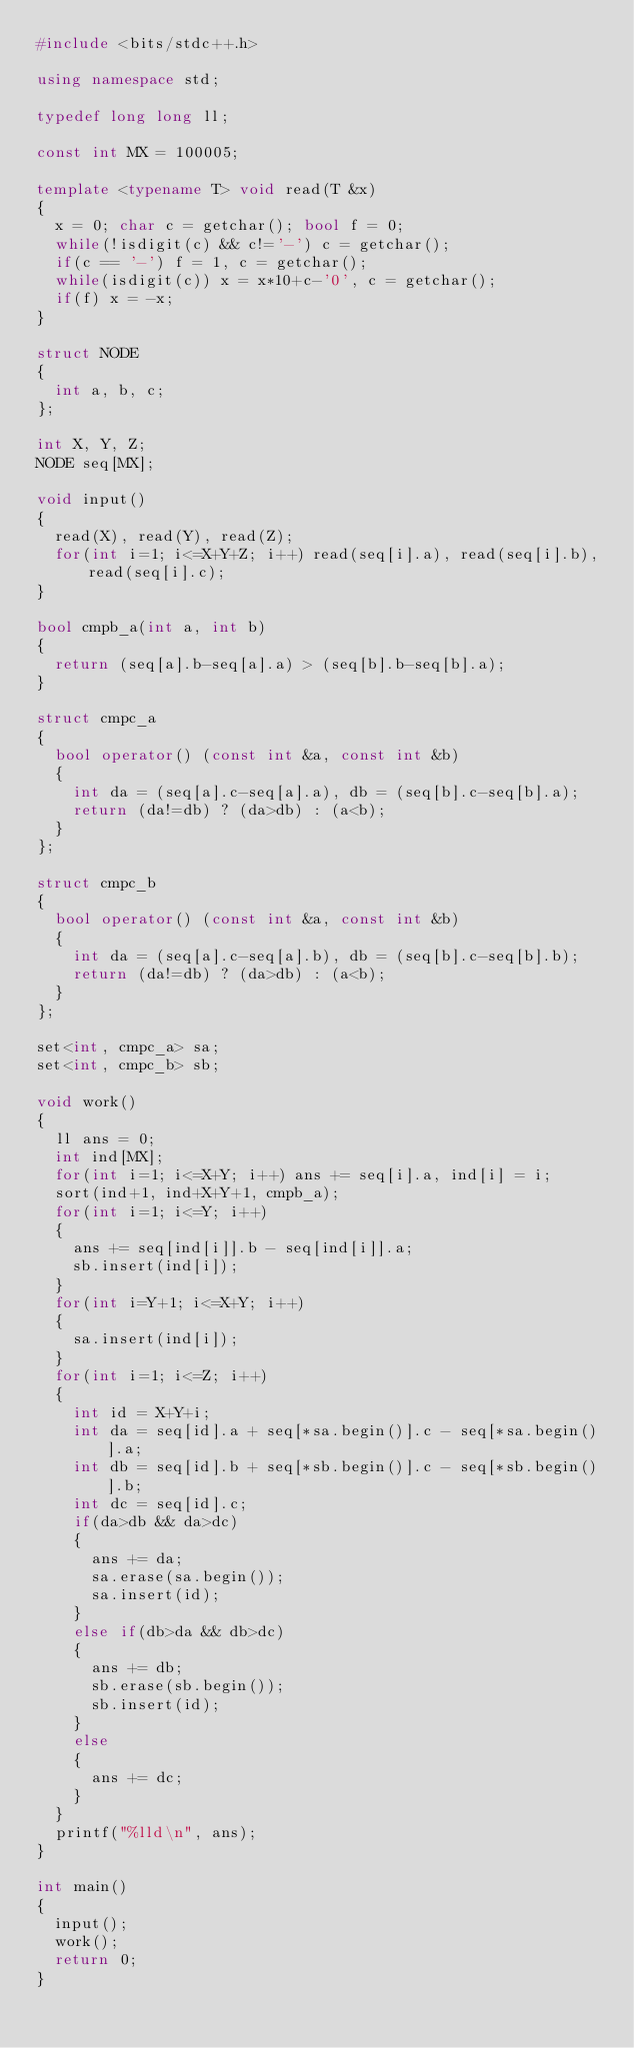<code> <loc_0><loc_0><loc_500><loc_500><_C++_>#include <bits/stdc++.h>

using namespace std;

typedef long long ll;

const int MX = 100005;

template <typename T> void read(T &x)
{
	x = 0; char c = getchar(); bool f = 0;
	while(!isdigit(c) && c!='-') c = getchar();
	if(c == '-') f = 1, c = getchar();
	while(isdigit(c)) x = x*10+c-'0', c = getchar();
	if(f) x = -x;
}

struct NODE
{
	int a, b, c;
};

int X, Y, Z;
NODE seq[MX];

void input()
{
	read(X), read(Y), read(Z);
	for(int i=1; i<=X+Y+Z; i++) read(seq[i].a), read(seq[i].b), read(seq[i].c);
}

bool cmpb_a(int a, int b)
{
	return (seq[a].b-seq[a].a) > (seq[b].b-seq[b].a);
}

struct cmpc_a
{
	bool operator() (const int &a, const int &b)
	{
		int da = (seq[a].c-seq[a].a), db = (seq[b].c-seq[b].a);
		return (da!=db) ? (da>db) : (a<b);
	}
};

struct cmpc_b
{
	bool operator() (const int &a, const int &b)
	{
		int da = (seq[a].c-seq[a].b), db = (seq[b].c-seq[b].b);
		return (da!=db) ? (da>db) : (a<b);
	}
};

set<int, cmpc_a> sa;
set<int, cmpc_b> sb;

void work()
{
	ll ans = 0;
	int ind[MX];
	for(int i=1; i<=X+Y; i++) ans += seq[i].a, ind[i] = i;
	sort(ind+1, ind+X+Y+1, cmpb_a);
	for(int i=1; i<=Y; i++)
	{
		ans += seq[ind[i]].b - seq[ind[i]].a;
		sb.insert(ind[i]);
	}
	for(int i=Y+1; i<=X+Y; i++)
	{
		sa.insert(ind[i]);
	}
	for(int i=1; i<=Z; i++)
	{
		int id = X+Y+i;
		int da = seq[id].a + seq[*sa.begin()].c - seq[*sa.begin()].a;
		int db = seq[id].b + seq[*sb.begin()].c - seq[*sb.begin()].b;
		int dc = seq[id].c;
		if(da>db && da>dc)
		{
			ans += da;
			sa.erase(sa.begin());
			sa.insert(id);
		}
		else if(db>da && db>dc)
		{
			ans += db;
			sb.erase(sb.begin());
			sb.insert(id);
		}
		else
		{
			ans += dc;
		}
	}
	printf("%lld\n", ans);
}

int main()
{
	input();
	work();
	return 0;
}</code> 